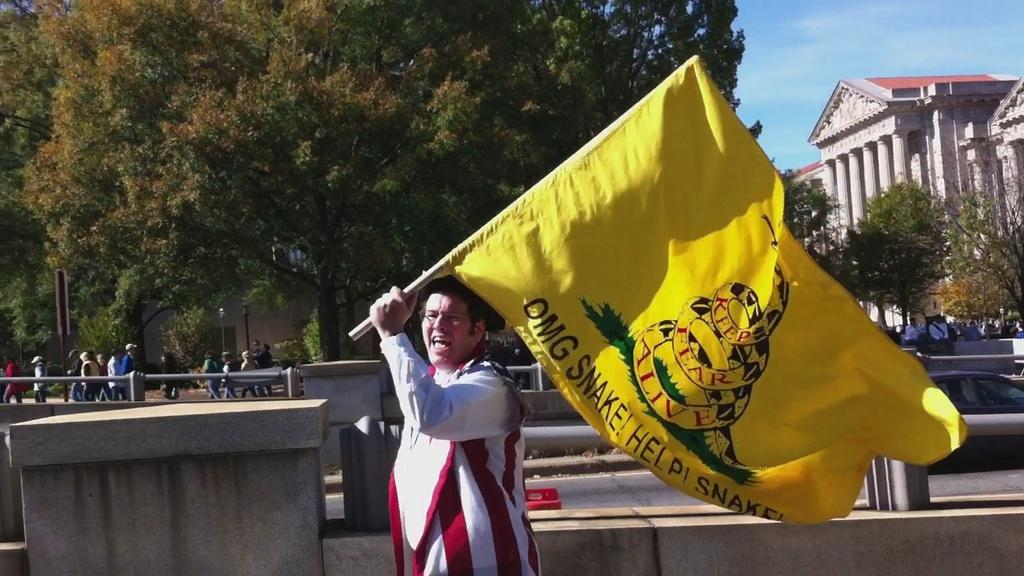<image>
Create a compact narrative representing the image presented. a man with a america flay custom holding a snake Dont Tread on Me flag 